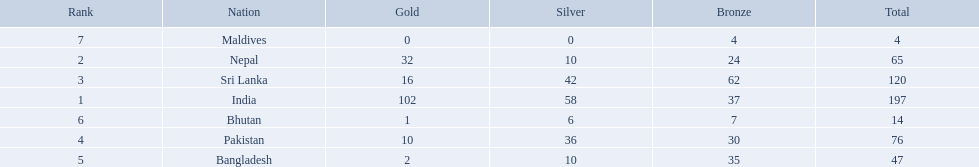What nations took part in 1999 south asian games? India, Nepal, Sri Lanka, Pakistan, Bangladesh, Bhutan, Maldives. Of those who earned gold medals? India, Nepal, Sri Lanka, Pakistan, Bangladesh, Bhutan. Which nation didn't earn any gold medals? Maldives. 